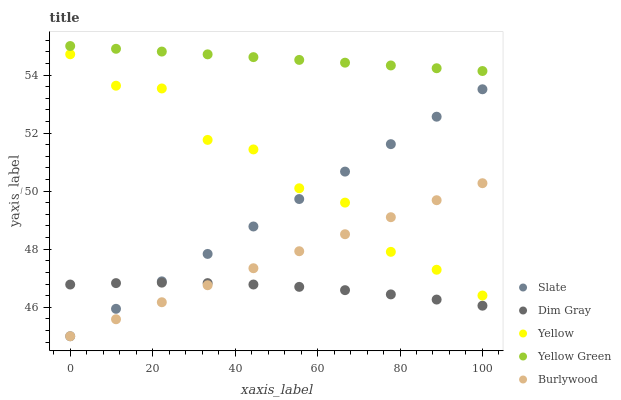Does Dim Gray have the minimum area under the curve?
Answer yes or no. Yes. Does Yellow Green have the maximum area under the curve?
Answer yes or no. Yes. Does Slate have the minimum area under the curve?
Answer yes or no. No. Does Slate have the maximum area under the curve?
Answer yes or no. No. Is Burlywood the smoothest?
Answer yes or no. Yes. Is Yellow the roughest?
Answer yes or no. Yes. Is Slate the smoothest?
Answer yes or no. No. Is Slate the roughest?
Answer yes or no. No. Does Burlywood have the lowest value?
Answer yes or no. Yes. Does Dim Gray have the lowest value?
Answer yes or no. No. Does Yellow Green have the highest value?
Answer yes or no. Yes. Does Slate have the highest value?
Answer yes or no. No. Is Dim Gray less than Yellow Green?
Answer yes or no. Yes. Is Yellow Green greater than Slate?
Answer yes or no. Yes. Does Burlywood intersect Dim Gray?
Answer yes or no. Yes. Is Burlywood less than Dim Gray?
Answer yes or no. No. Is Burlywood greater than Dim Gray?
Answer yes or no. No. Does Dim Gray intersect Yellow Green?
Answer yes or no. No. 